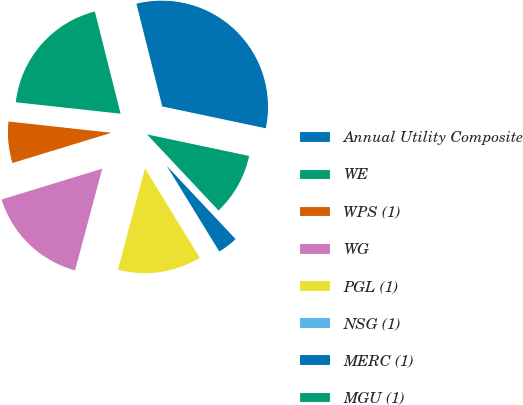<chart> <loc_0><loc_0><loc_500><loc_500><pie_chart><fcel>Annual Utility Composite<fcel>WE<fcel>WPS (1)<fcel>WG<fcel>PGL (1)<fcel>NSG (1)<fcel>MERC (1)<fcel>MGU (1)<nl><fcel>32.23%<fcel>19.34%<fcel>6.46%<fcel>16.12%<fcel>12.9%<fcel>0.02%<fcel>3.24%<fcel>9.68%<nl></chart> 